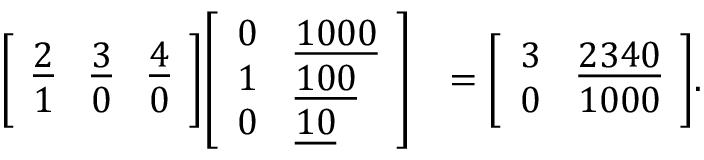Convert formula to latex. <formula><loc_0><loc_0><loc_500><loc_500>{ \begin{array} { r l } { { \left [ \begin{array} { l l l } { { \underline { 2 } } } & { { \underline { 3 } } } & { { \underline { 4 } } } \\ { 1 } & { 0 } & { 0 } \end{array} \right ] } { \left [ \begin{array} { l l } { 0 } & { { \underline { 1 0 0 0 } } } \\ { 1 } & { { \underline { 1 0 0 } } } \\ { 0 } & { { \underline { 1 0 } } } \end{array} \right ] } } & { = { \left [ \begin{array} { l l } { 3 } & { { \underline { 2 3 4 0 } } } \\ { 0 } & { 1 0 0 0 } \end{array} \right ] } . } \end{array} }</formula> 